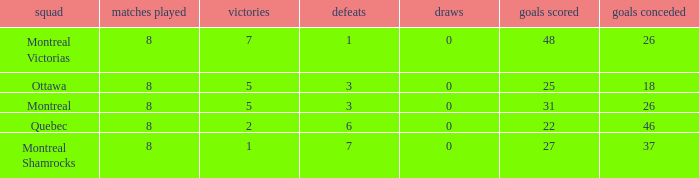How many losses did the team with 22 goals for andmore than 8 games played have? 0.0. 